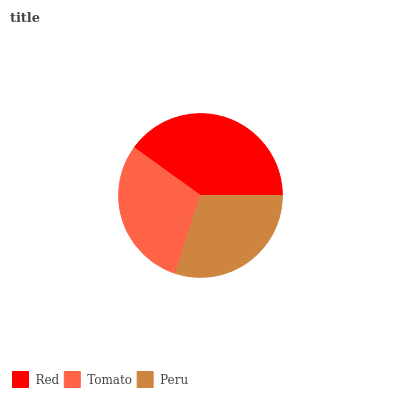Is Peru the minimum?
Answer yes or no. Yes. Is Red the maximum?
Answer yes or no. Yes. Is Tomato the minimum?
Answer yes or no. No. Is Tomato the maximum?
Answer yes or no. No. Is Red greater than Tomato?
Answer yes or no. Yes. Is Tomato less than Red?
Answer yes or no. Yes. Is Tomato greater than Red?
Answer yes or no. No. Is Red less than Tomato?
Answer yes or no. No. Is Tomato the high median?
Answer yes or no. Yes. Is Tomato the low median?
Answer yes or no. Yes. Is Red the high median?
Answer yes or no. No. Is Peru the low median?
Answer yes or no. No. 